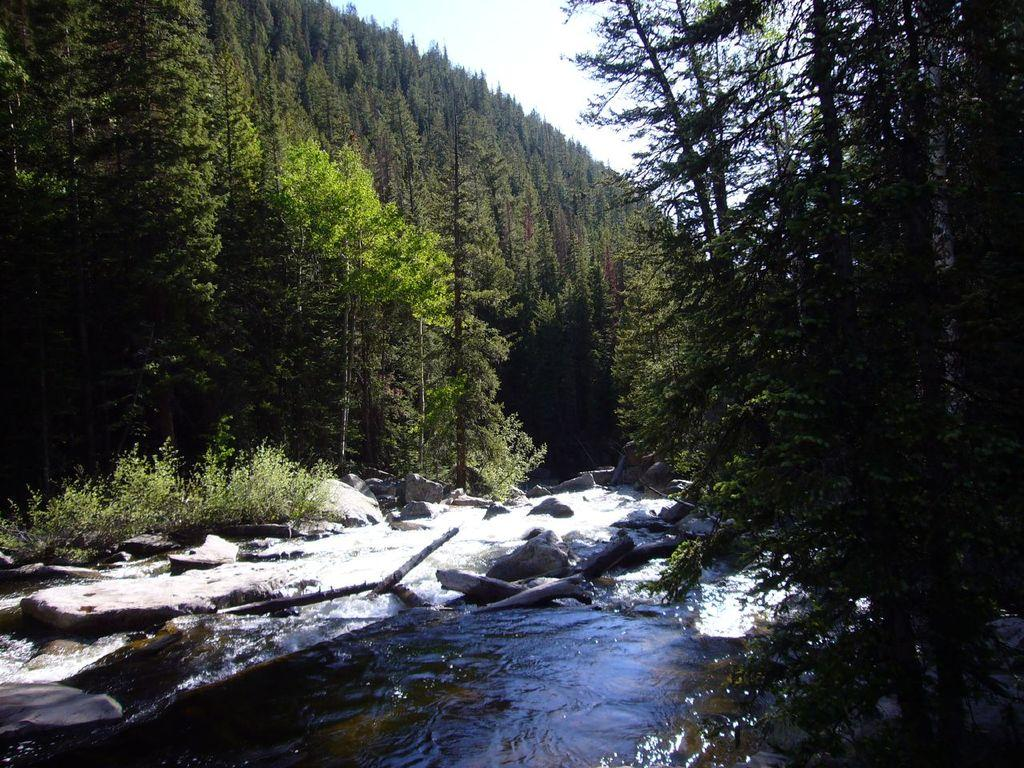What type of vegetation can be seen in the image? There are trees in the image. What else can be seen in the image besides trees? There are other unspecified things in the image. What is visible in the background of the image? The sky is visible in the background of the image. Can you describe the water visible in the image? Unfortunately, the facts provided do not give any details about the water, so we cannot describe it further. How many men are standing next to the cactus in the image? There is no cactus or men present in the image. 